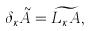Convert formula to latex. <formula><loc_0><loc_0><loc_500><loc_500>\delta _ { \kappa } \tilde { A } = { \widetilde { L _ { \kappa } A } } ,</formula> 